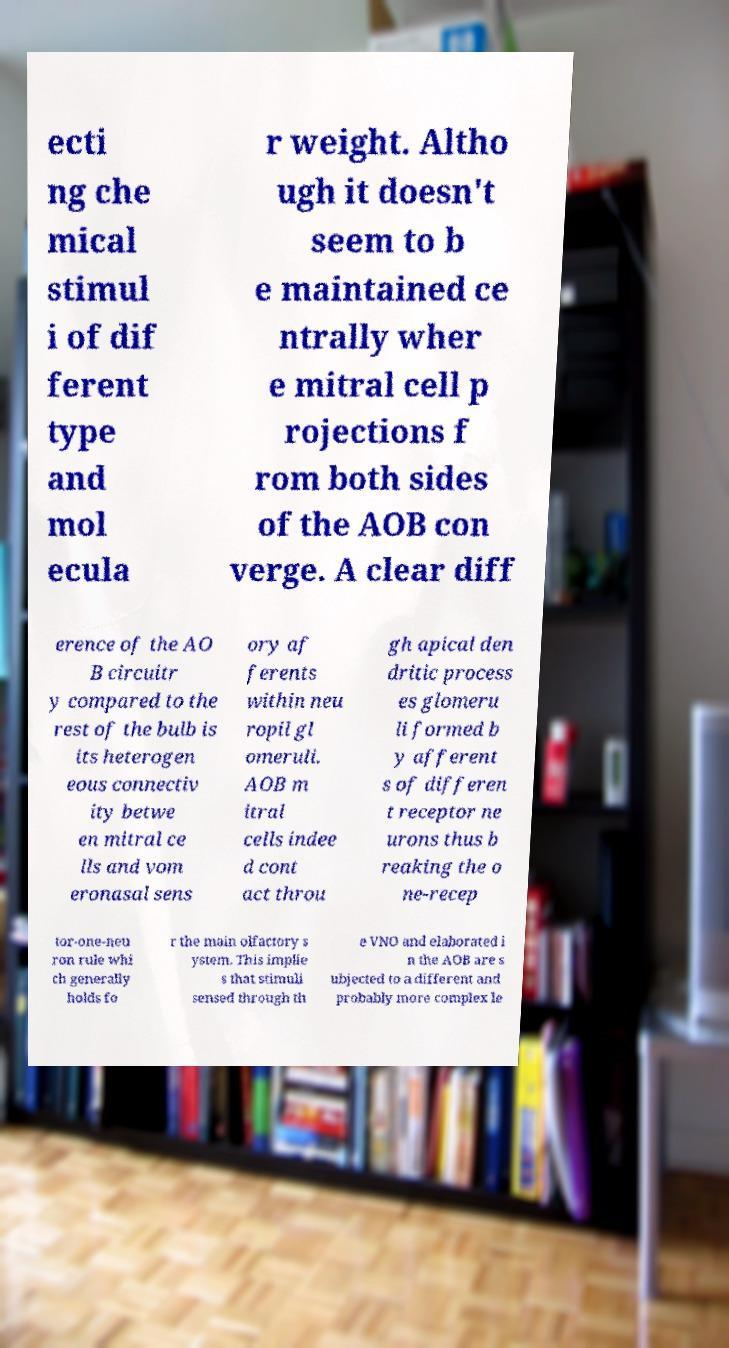There's text embedded in this image that I need extracted. Can you transcribe it verbatim? ecti ng che mical stimul i of dif ferent type and mol ecula r weight. Altho ugh it doesn't seem to b e maintained ce ntrally wher e mitral cell p rojections f rom both sides of the AOB con verge. A clear diff erence of the AO B circuitr y compared to the rest of the bulb is its heterogen eous connectiv ity betwe en mitral ce lls and vom eronasal sens ory af ferents within neu ropil gl omeruli. AOB m itral cells indee d cont act throu gh apical den dritic process es glomeru li formed b y afferent s of differen t receptor ne urons thus b reaking the o ne-recep tor-one-neu ron rule whi ch generally holds fo r the main olfactory s ystem. This implie s that stimuli sensed through th e VNO and elaborated i n the AOB are s ubjected to a different and probably more complex le 